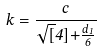<formula> <loc_0><loc_0><loc_500><loc_500>k = \frac { c } { \sqrt { [ } 4 ] { + \frac { d _ { 1 } } { 6 } } }</formula> 